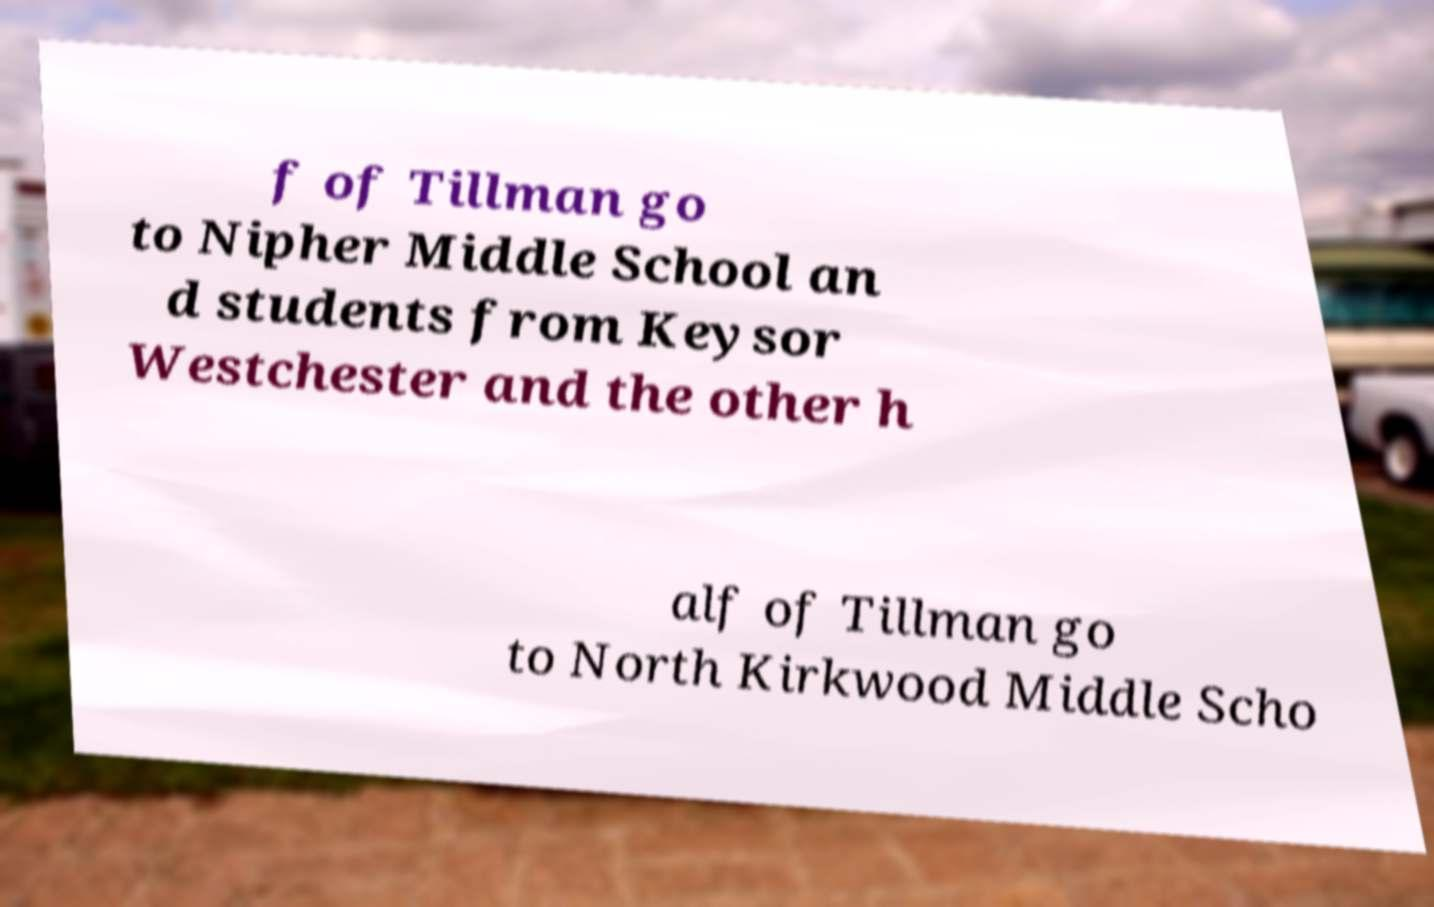Can you accurately transcribe the text from the provided image for me? f of Tillman go to Nipher Middle School an d students from Keysor Westchester and the other h alf of Tillman go to North Kirkwood Middle Scho 